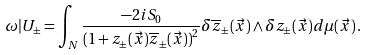Convert formula to latex. <formula><loc_0><loc_0><loc_500><loc_500>\omega | U _ { \pm } = \int _ { N } \frac { - 2 i S _ { 0 } } { \left ( 1 + z _ { \pm } ( \vec { x } ) \overline { z } _ { \pm } ( \vec { x } ) \right ) ^ { 2 } } \delta \overline { z } _ { \pm } ( \vec { x } ) \wedge \delta z _ { \pm } ( \vec { x } ) d \mu ( \vec { x } ) \, .</formula> 